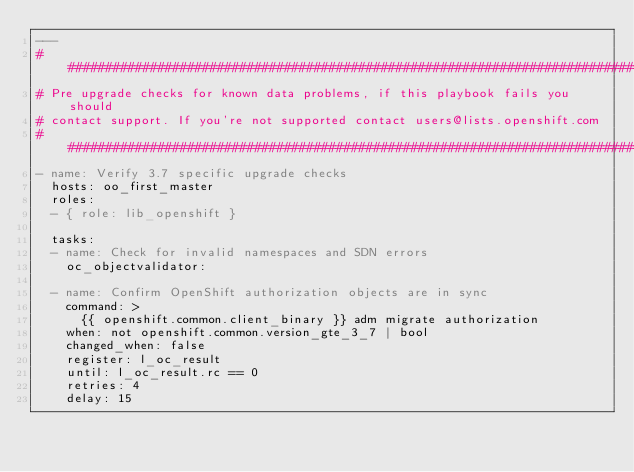<code> <loc_0><loc_0><loc_500><loc_500><_YAML_>---
###############################################################################
# Pre upgrade checks for known data problems, if this playbook fails you should
# contact support. If you're not supported contact users@lists.openshift.com
###############################################################################
- name: Verify 3.7 specific upgrade checks
  hosts: oo_first_master
  roles:
  - { role: lib_openshift }

  tasks:
  - name: Check for invalid namespaces and SDN errors
    oc_objectvalidator:

  - name: Confirm OpenShift authorization objects are in sync
    command: >
      {{ openshift.common.client_binary }} adm migrate authorization
    when: not openshift.common.version_gte_3_7 | bool
    changed_when: false
    register: l_oc_result
    until: l_oc_result.rc == 0
    retries: 4
    delay: 15
</code> 